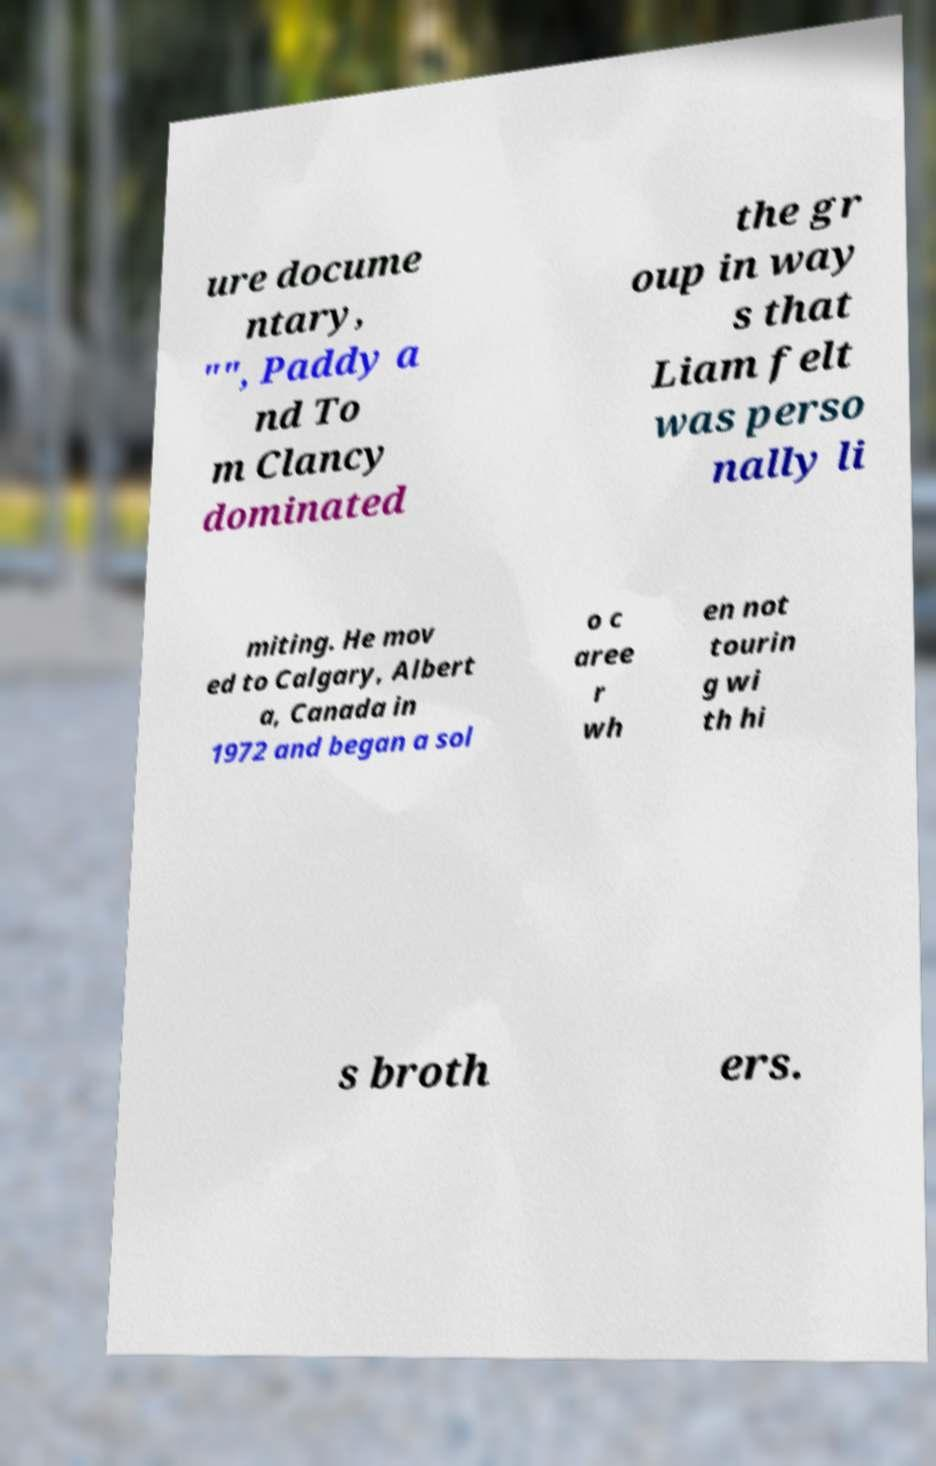Please read and relay the text visible in this image. What does it say? ure docume ntary, "", Paddy a nd To m Clancy dominated the gr oup in way s that Liam felt was perso nally li miting. He mov ed to Calgary, Albert a, Canada in 1972 and began a sol o c aree r wh en not tourin g wi th hi s broth ers. 